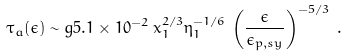Convert formula to latex. <formula><loc_0><loc_0><loc_500><loc_500>\tau _ { a } ( \epsilon ) \sim g 5 . 1 \times 1 0 ^ { - 2 } \, x _ { 1 } ^ { 2 / 3 } \eta _ { 1 } ^ { - 1 / 6 } \, \left ( \frac { \epsilon } { \epsilon _ { p , s y } } \right ) ^ { - 5 / 3 } \, .</formula> 